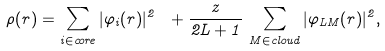<formula> <loc_0><loc_0><loc_500><loc_500>\rho ( r ) = \sum _ { i \in c o r e } | \varphi _ { i } ( r ) | ^ { 2 } \ + \frac { z } { 2 L + 1 } \, \sum _ { M \in c l o u d } | \varphi _ { L M } ( r ) | ^ { 2 } ,</formula> 